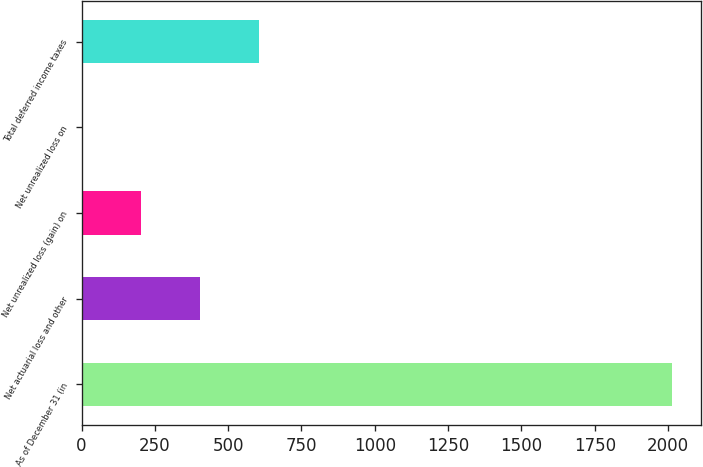Convert chart. <chart><loc_0><loc_0><loc_500><loc_500><bar_chart><fcel>As of December 31 (in<fcel>Net actuarial loss and other<fcel>Net unrealized loss (gain) on<fcel>Net unrealized loss on<fcel>Total deferred income taxes<nl><fcel>2013<fcel>402.76<fcel>201.48<fcel>0.2<fcel>604.04<nl></chart> 